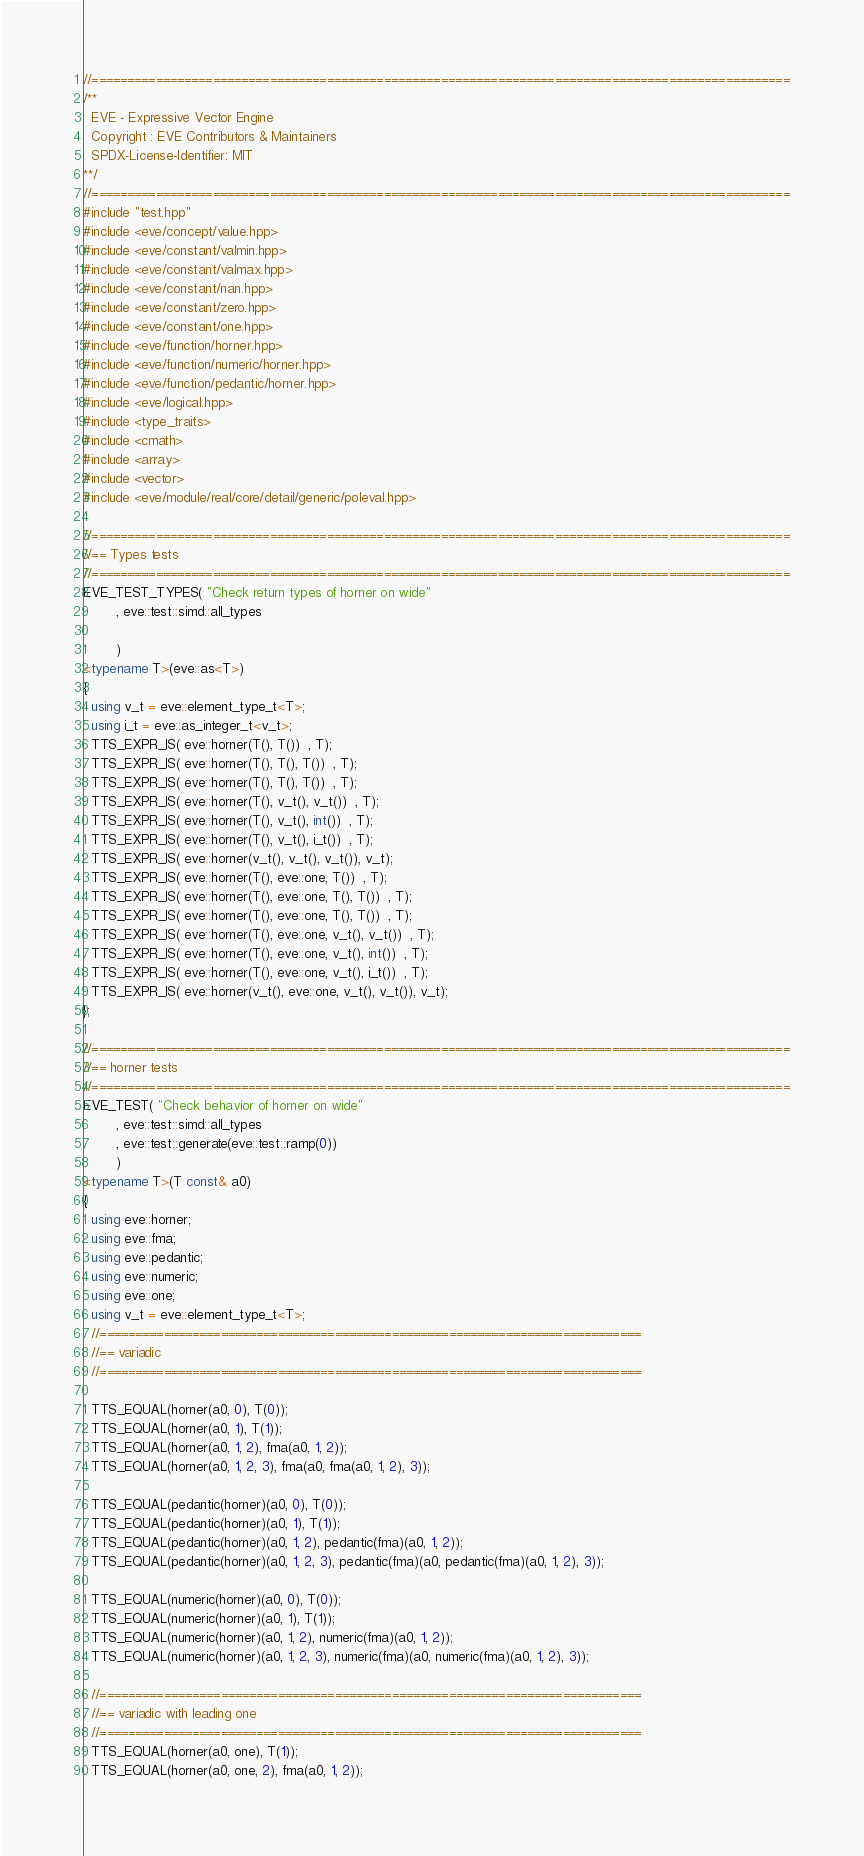Convert code to text. <code><loc_0><loc_0><loc_500><loc_500><_C++_>//==================================================================================================
/**
  EVE - Expressive Vector Engine
  Copyright : EVE Contributors & Maintainers
  SPDX-License-Identifier: MIT
**/
//==================================================================================================
#include "test.hpp"
#include <eve/concept/value.hpp>
#include <eve/constant/valmin.hpp>
#include <eve/constant/valmax.hpp>
#include <eve/constant/nan.hpp>
#include <eve/constant/zero.hpp>
#include <eve/constant/one.hpp>
#include <eve/function/horner.hpp>
#include <eve/function/numeric/horner.hpp>
#include <eve/function/pedantic/horner.hpp>
#include <eve/logical.hpp>
#include <type_traits>
#include <cmath>
#include <array>
#include <vector>
#include <eve/module/real/core/detail/generic/poleval.hpp>

//==================================================================================================
//== Types tests
//==================================================================================================
EVE_TEST_TYPES( "Check return types of horner on wide"
        , eve::test::simd::all_types

        )
<typename T>(eve::as<T>)
{
  using v_t = eve::element_type_t<T>;
  using i_t = eve::as_integer_t<v_t>;
  TTS_EXPR_IS( eve::horner(T(), T())  , T);
  TTS_EXPR_IS( eve::horner(T(), T(), T())  , T);
  TTS_EXPR_IS( eve::horner(T(), T(), T())  , T);
  TTS_EXPR_IS( eve::horner(T(), v_t(), v_t())  , T);
  TTS_EXPR_IS( eve::horner(T(), v_t(), int())  , T);
  TTS_EXPR_IS( eve::horner(T(), v_t(), i_t())  , T);
  TTS_EXPR_IS( eve::horner(v_t(), v_t(), v_t()), v_t);
  TTS_EXPR_IS( eve::horner(T(), eve::one, T())  , T);
  TTS_EXPR_IS( eve::horner(T(), eve::one, T(), T())  , T);
  TTS_EXPR_IS( eve::horner(T(), eve::one, T(), T())  , T);
  TTS_EXPR_IS( eve::horner(T(), eve::one, v_t(), v_t())  , T);
  TTS_EXPR_IS( eve::horner(T(), eve::one, v_t(), int())  , T);
  TTS_EXPR_IS( eve::horner(T(), eve::one, v_t(), i_t())  , T);
  TTS_EXPR_IS( eve::horner(v_t(), eve::one, v_t(), v_t()), v_t);
};

//==================================================================================================
//== horner tests
//==================================================================================================
EVE_TEST( "Check behavior of horner on wide"
        , eve::test::simd::all_types
        , eve::test::generate(eve::test::ramp(0))
        )
<typename T>(T const& a0)
{
  using eve::horner;
  using eve::fma;
  using eve::pedantic;
  using eve::numeric;
  using eve::one;
  using v_t = eve::element_type_t<T>;
  //============================================================================
  //== variadic
  //============================================================================

  TTS_EQUAL(horner(a0, 0), T(0));
  TTS_EQUAL(horner(a0, 1), T(1));
  TTS_EQUAL(horner(a0, 1, 2), fma(a0, 1, 2));
  TTS_EQUAL(horner(a0, 1, 2, 3), fma(a0, fma(a0, 1, 2), 3));

  TTS_EQUAL(pedantic(horner)(a0, 0), T(0));
  TTS_EQUAL(pedantic(horner)(a0, 1), T(1));
  TTS_EQUAL(pedantic(horner)(a0, 1, 2), pedantic(fma)(a0, 1, 2));
  TTS_EQUAL(pedantic(horner)(a0, 1, 2, 3), pedantic(fma)(a0, pedantic(fma)(a0, 1, 2), 3));

  TTS_EQUAL(numeric(horner)(a0, 0), T(0));
  TTS_EQUAL(numeric(horner)(a0, 1), T(1));
  TTS_EQUAL(numeric(horner)(a0, 1, 2), numeric(fma)(a0, 1, 2));
  TTS_EQUAL(numeric(horner)(a0, 1, 2, 3), numeric(fma)(a0, numeric(fma)(a0, 1, 2), 3));

  //============================================================================
  //== variadic with leading one
  //============================================================================
  TTS_EQUAL(horner(a0, one), T(1));
  TTS_EQUAL(horner(a0, one, 2), fma(a0, 1, 2));</code> 